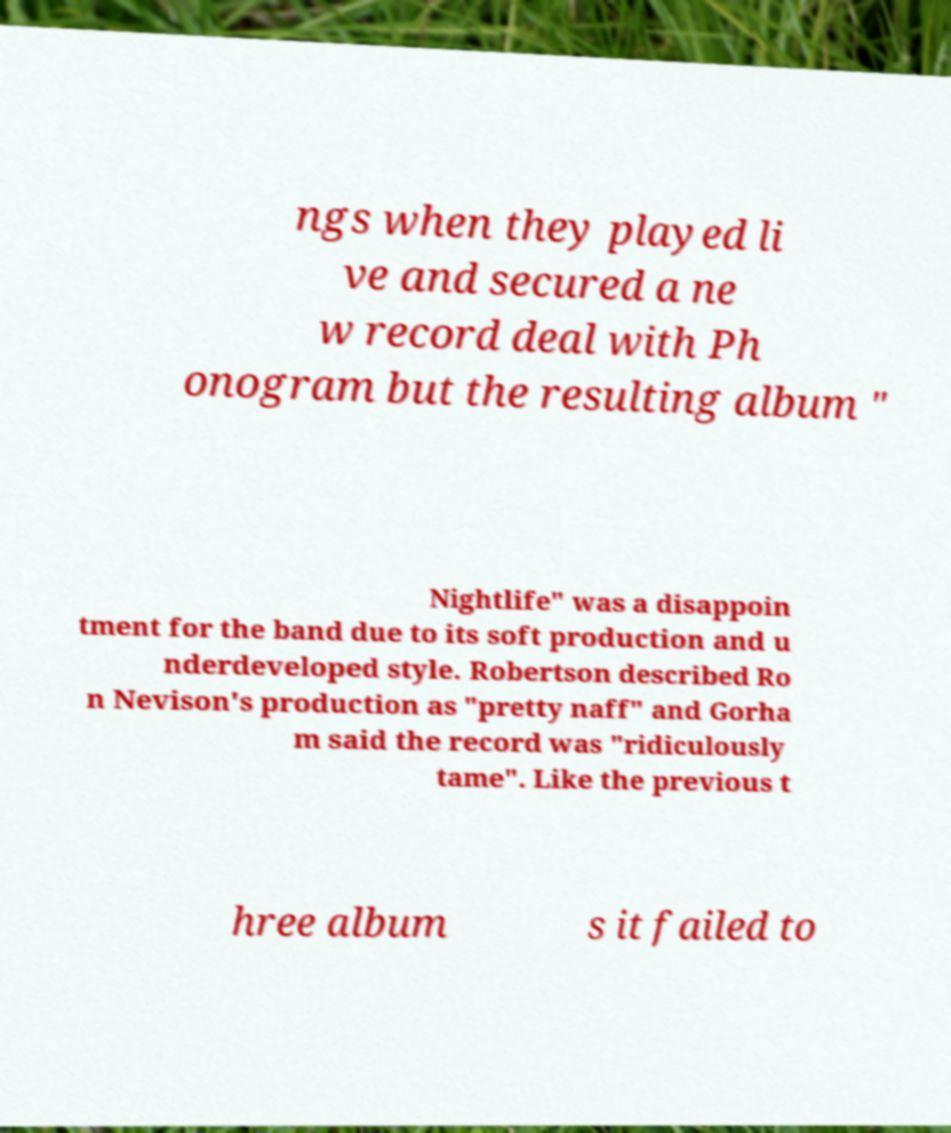Could you extract and type out the text from this image? ngs when they played li ve and secured a ne w record deal with Ph onogram but the resulting album " Nightlife" was a disappoin tment for the band due to its soft production and u nderdeveloped style. Robertson described Ro n Nevison's production as "pretty naff" and Gorha m said the record was "ridiculously tame". Like the previous t hree album s it failed to 